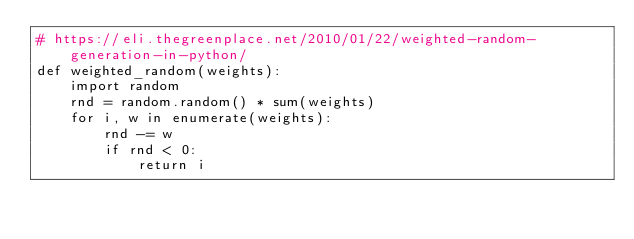Convert code to text. <code><loc_0><loc_0><loc_500><loc_500><_Python_># https://eli.thegreenplace.net/2010/01/22/weighted-random-generation-in-python/
def weighted_random(weights):
    import random
    rnd = random.random() * sum(weights)
    for i, w in enumerate(weights):
        rnd -= w
        if rnd < 0:
            return i
</code> 